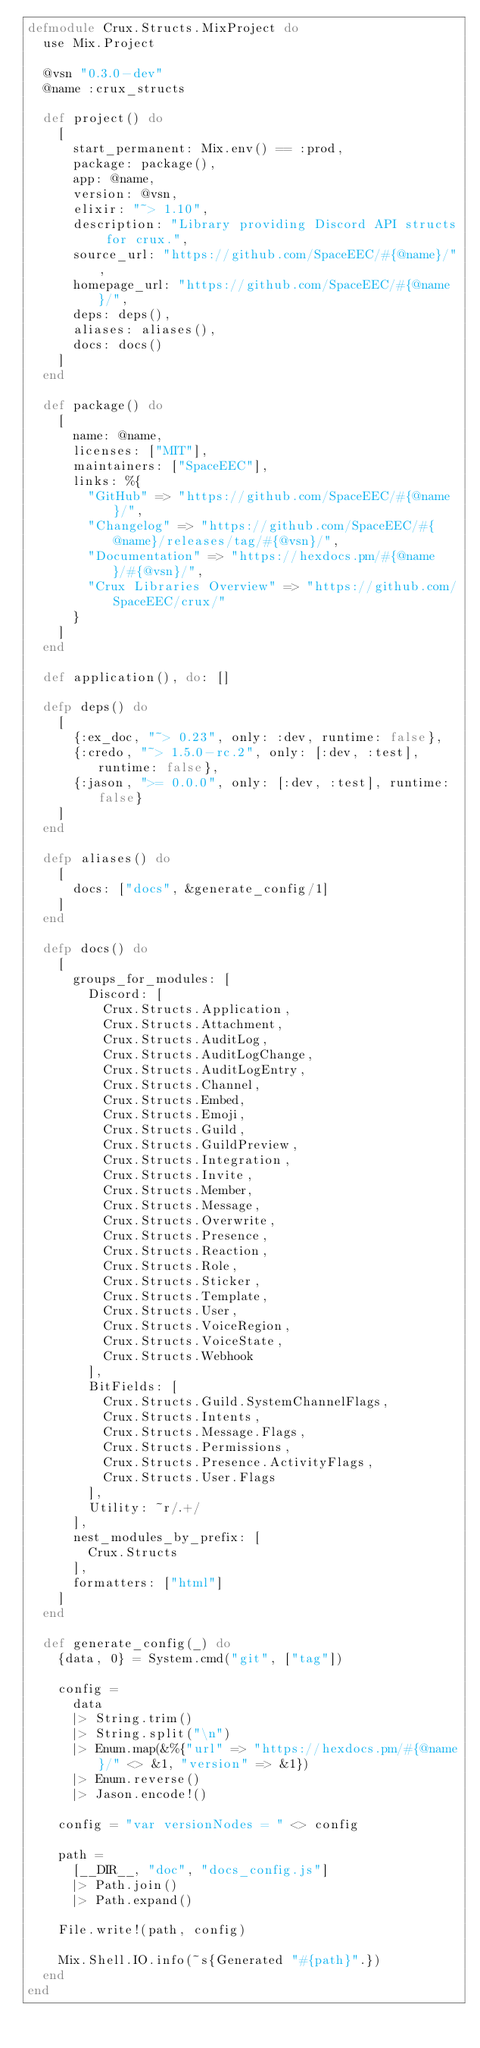<code> <loc_0><loc_0><loc_500><loc_500><_Elixir_>defmodule Crux.Structs.MixProject do
  use Mix.Project

  @vsn "0.3.0-dev"
  @name :crux_structs

  def project() do
    [
      start_permanent: Mix.env() == :prod,
      package: package(),
      app: @name,
      version: @vsn,
      elixir: "~> 1.10",
      description: "Library providing Discord API structs for crux.",
      source_url: "https://github.com/SpaceEEC/#{@name}/",
      homepage_url: "https://github.com/SpaceEEC/#{@name}/",
      deps: deps(),
      aliases: aliases(),
      docs: docs()
    ]
  end

  def package() do
    [
      name: @name,
      licenses: ["MIT"],
      maintainers: ["SpaceEEC"],
      links: %{
        "GitHub" => "https://github.com/SpaceEEC/#{@name}/",
        "Changelog" => "https://github.com/SpaceEEC/#{@name}/releases/tag/#{@vsn}/",
        "Documentation" => "https://hexdocs.pm/#{@name}/#{@vsn}/",
        "Crux Libraries Overview" => "https://github.com/SpaceEEC/crux/"
      }
    ]
  end

  def application(), do: []

  defp deps() do
    [
      {:ex_doc, "~> 0.23", only: :dev, runtime: false},
      {:credo, "~> 1.5.0-rc.2", only: [:dev, :test], runtime: false},
      {:jason, ">= 0.0.0", only: [:dev, :test], runtime: false}
    ]
  end

  defp aliases() do
    [
      docs: ["docs", &generate_config/1]
    ]
  end

  defp docs() do
    [
      groups_for_modules: [
        Discord: [
          Crux.Structs.Application,
          Crux.Structs.Attachment,
          Crux.Structs.AuditLog,
          Crux.Structs.AuditLogChange,
          Crux.Structs.AuditLogEntry,
          Crux.Structs.Channel,
          Crux.Structs.Embed,
          Crux.Structs.Emoji,
          Crux.Structs.Guild,
          Crux.Structs.GuildPreview,
          Crux.Structs.Integration,
          Crux.Structs.Invite,
          Crux.Structs.Member,
          Crux.Structs.Message,
          Crux.Structs.Overwrite,
          Crux.Structs.Presence,
          Crux.Structs.Reaction,
          Crux.Structs.Role,
          Crux.Structs.Sticker,
          Crux.Structs.Template,
          Crux.Structs.User,
          Crux.Structs.VoiceRegion,
          Crux.Structs.VoiceState,
          Crux.Structs.Webhook
        ],
        BitFields: [
          Crux.Structs.Guild.SystemChannelFlags,
          Crux.Structs.Intents,
          Crux.Structs.Message.Flags,
          Crux.Structs.Permissions,
          Crux.Structs.Presence.ActivityFlags,
          Crux.Structs.User.Flags
        ],
        Utility: ~r/.+/
      ],
      nest_modules_by_prefix: [
        Crux.Structs
      ],
      formatters: ["html"]
    ]
  end

  def generate_config(_) do
    {data, 0} = System.cmd("git", ["tag"])

    config =
      data
      |> String.trim()
      |> String.split("\n")
      |> Enum.map(&%{"url" => "https://hexdocs.pm/#{@name}/" <> &1, "version" => &1})
      |> Enum.reverse()
      |> Jason.encode!()

    config = "var versionNodes = " <> config

    path =
      [__DIR__, "doc", "docs_config.js"]
      |> Path.join()
      |> Path.expand()

    File.write!(path, config)

    Mix.Shell.IO.info(~s{Generated "#{path}".})
  end
end
</code> 